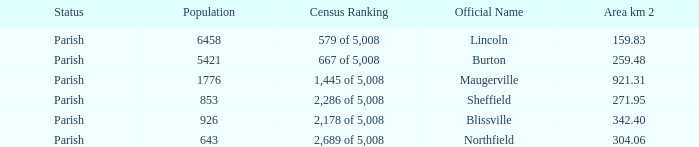What is the status(es) of the place with an area of 304.06 km2? Parish. 